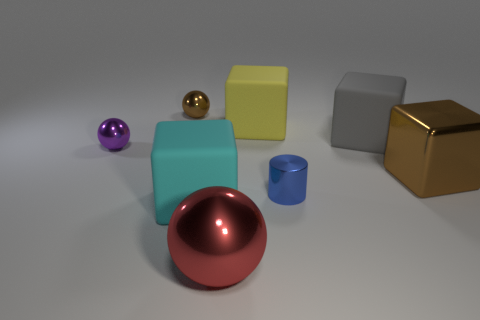Add 1 tiny things. How many objects exist? 9 Subtract all cylinders. How many objects are left? 7 Subtract all big cyan balls. Subtract all small purple metal spheres. How many objects are left? 7 Add 4 gray rubber blocks. How many gray rubber blocks are left? 5 Add 6 gray rubber blocks. How many gray rubber blocks exist? 7 Subtract 0 cyan cylinders. How many objects are left? 8 